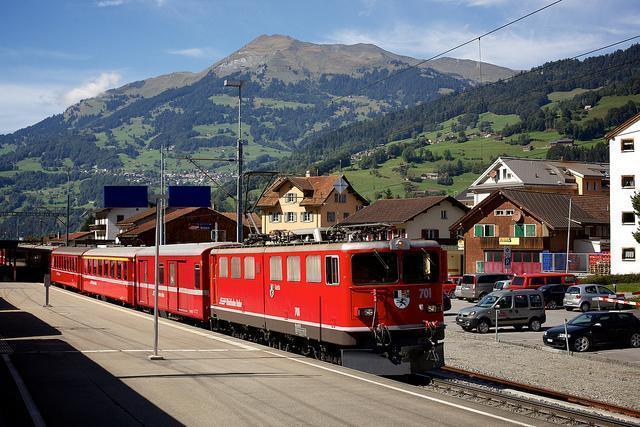How many cars are in the picture?
Give a very brief answer. 2. 